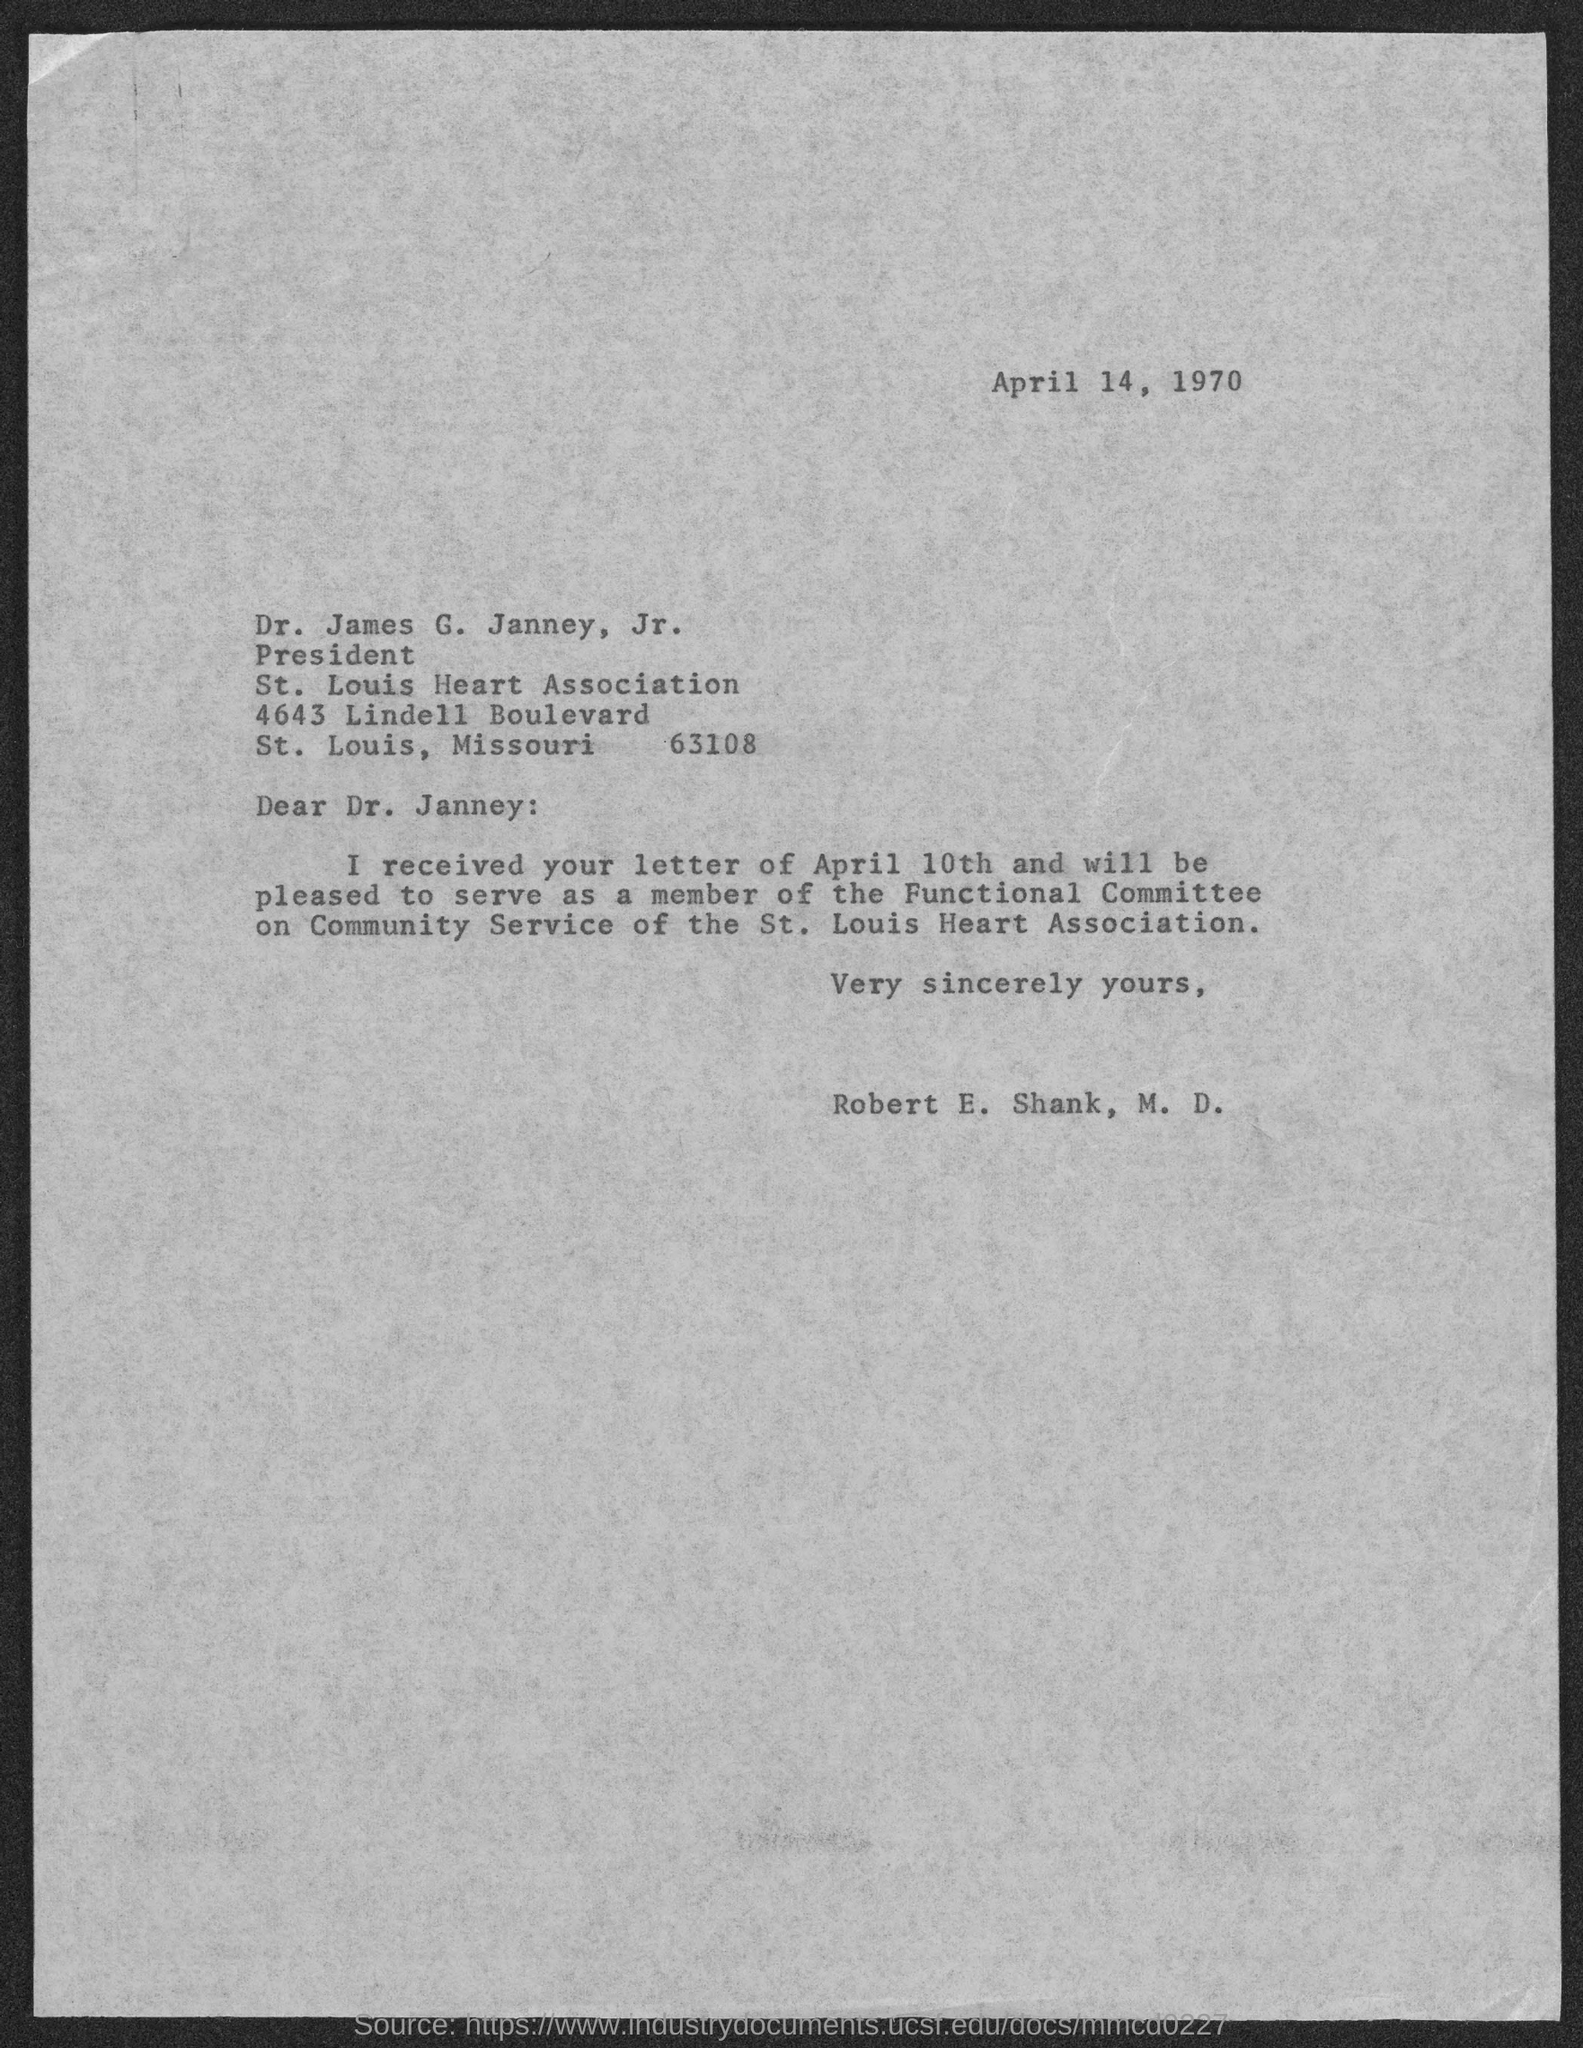On which date the letter is dated on?
Ensure brevity in your answer.  April 14, 1970. Who is the president of st.louis heart association?
Your answer should be very brief. Dr. James G. Janney, Jr. What is the postal code of St. Louis heart association?
Provide a short and direct response. 63108. To whom this letter is written to?
Keep it short and to the point. Dr. James G. Janney, Jr. Who wrote this letter?
Your answer should be very brief. Robert E. Shank, M.D. Who wants to serve as member of the functional committee?
Your answer should be very brief. Robert E. Shank, M.D. 